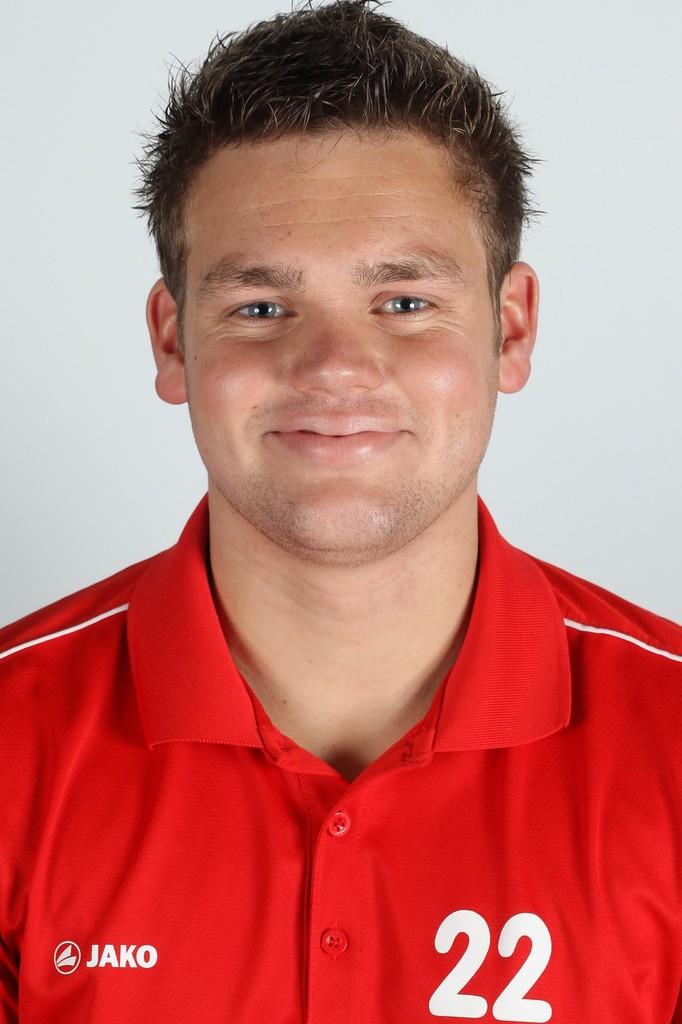What team brand is on the shirt?
Provide a succinct answer. Jako. 